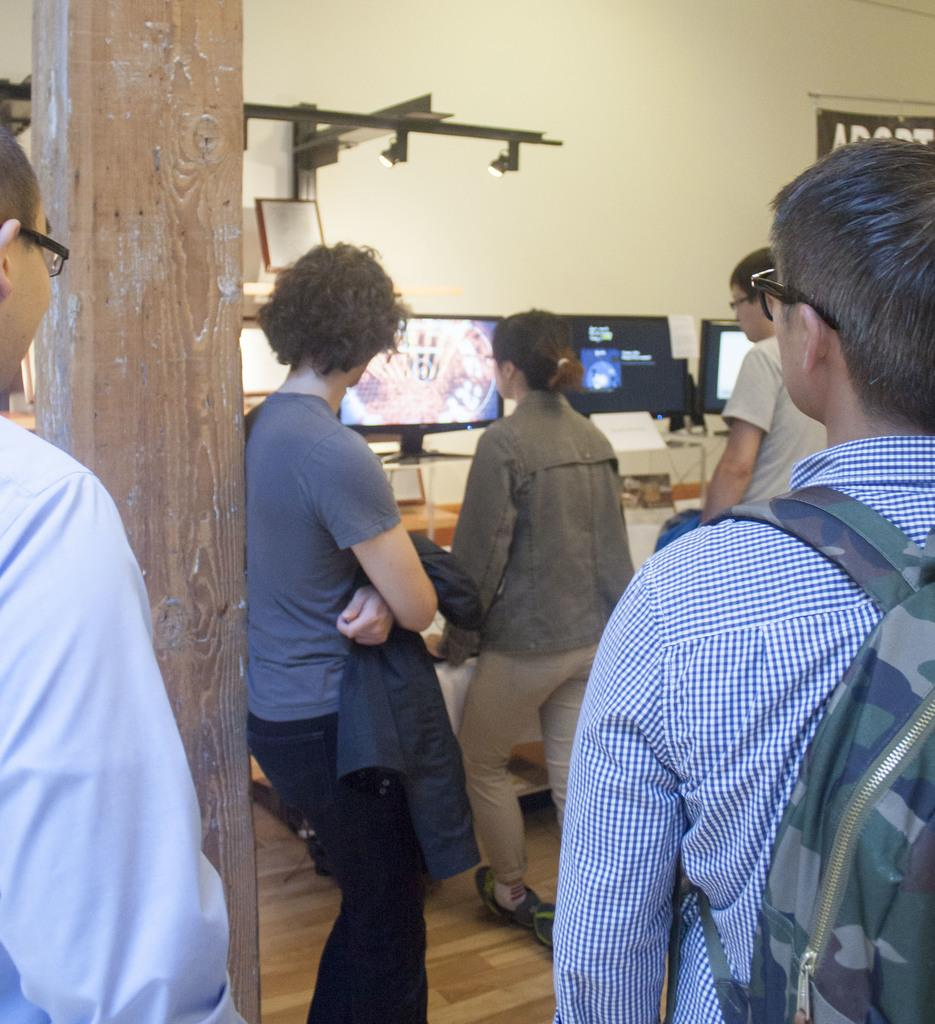How many people are in the image? There is a group of persons standing in the image. What can be seen in the background of the image? There are monitors and a wall in the background of the image. What grade of goat is being discussed in the image? There is no mention of a goat or any discussion about grades in the image. 